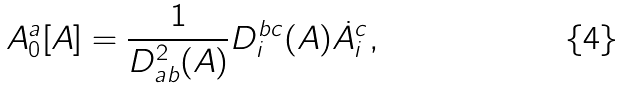<formula> <loc_0><loc_0><loc_500><loc_500>A ^ { a } _ { 0 } [ { A } ] = \frac { 1 } { D ^ { 2 } _ { a b } ( { A } ) } D ^ { b c } _ { i } ( { A } ) \dot { A } _ { i } ^ { c } ,</formula> 